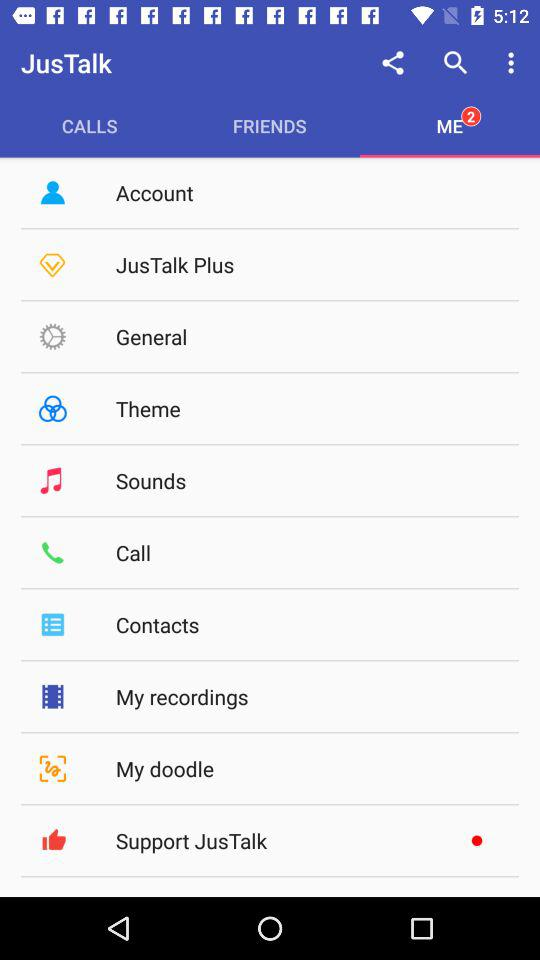What is the selected tab? The selected tab is "ME". 